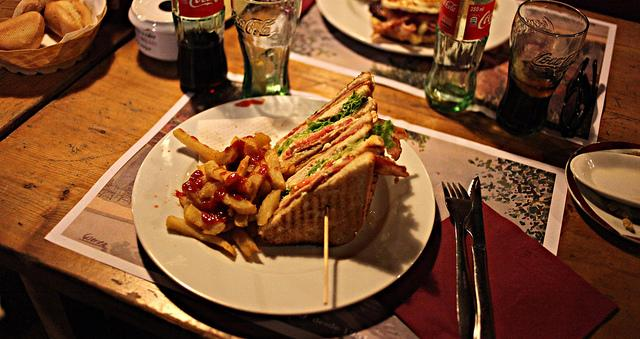What is the name of this sandwich? Please explain your reasoning. club sandwich. That's a club sandwich on the plate. 